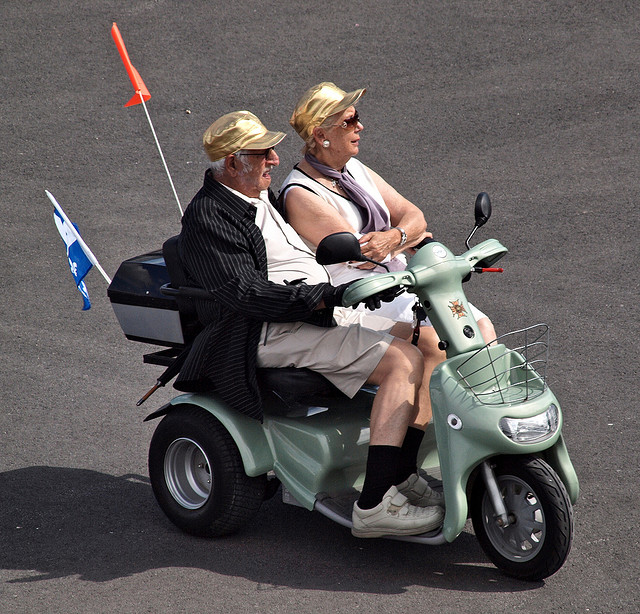<image>What country's flag is on the back of the scooter? It is unknown what country's flag is on the back of the scooter. What country's flag is on the back of the scooter? I don't know what country's flag is on the back of the scooter. It can be Switzerland, Britain, Italy, Sweden, or Norway. 